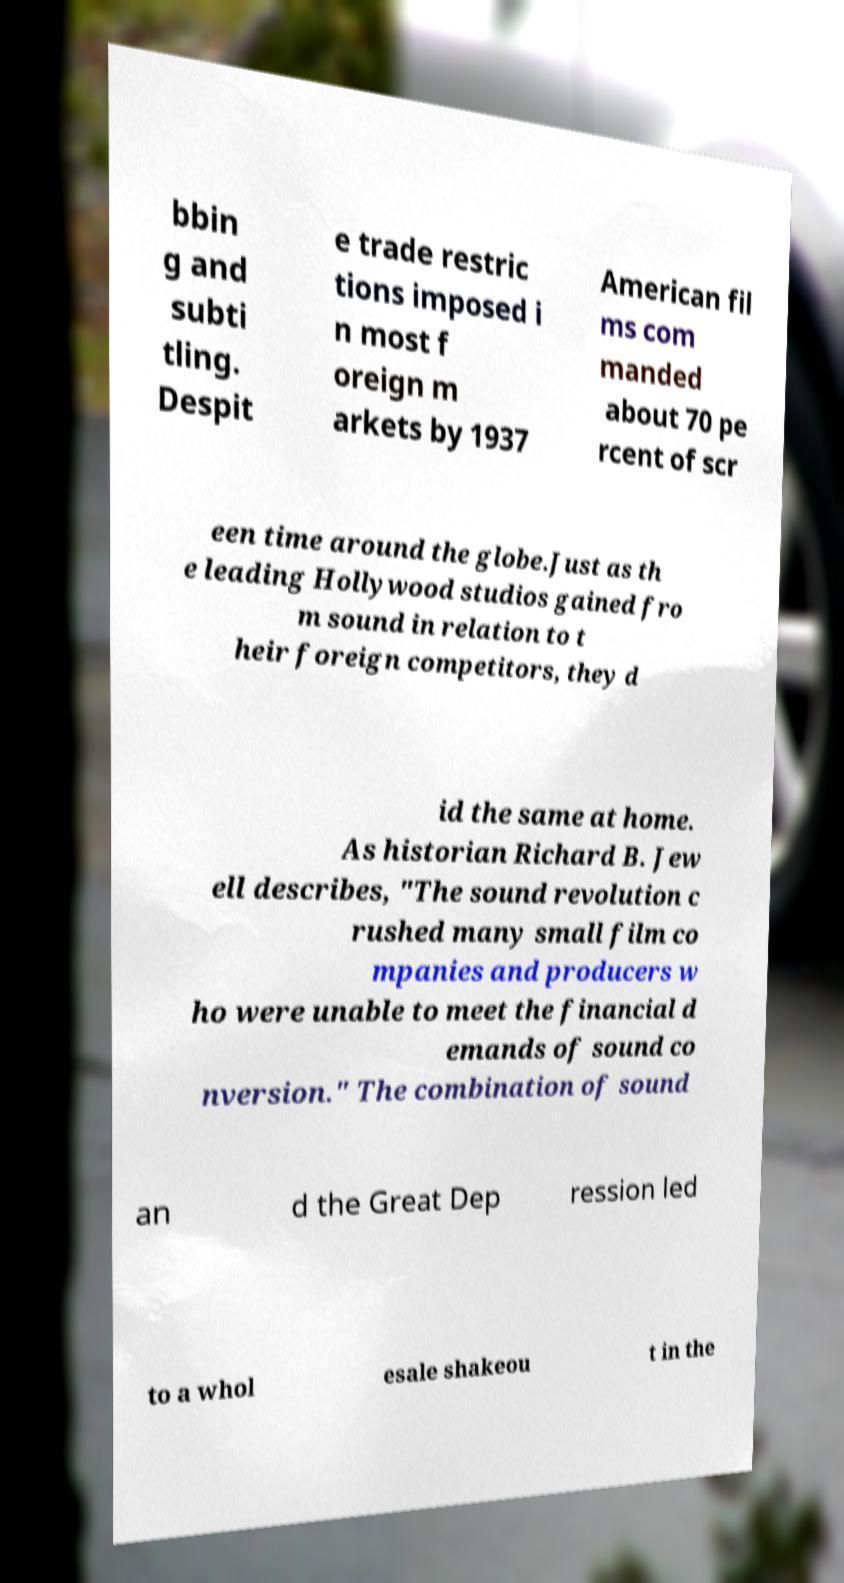Please read and relay the text visible in this image. What does it say? bbin g and subti tling. Despit e trade restric tions imposed i n most f oreign m arkets by 1937 American fil ms com manded about 70 pe rcent of scr een time around the globe.Just as th e leading Hollywood studios gained fro m sound in relation to t heir foreign competitors, they d id the same at home. As historian Richard B. Jew ell describes, "The sound revolution c rushed many small film co mpanies and producers w ho were unable to meet the financial d emands of sound co nversion." The combination of sound an d the Great Dep ression led to a whol esale shakeou t in the 